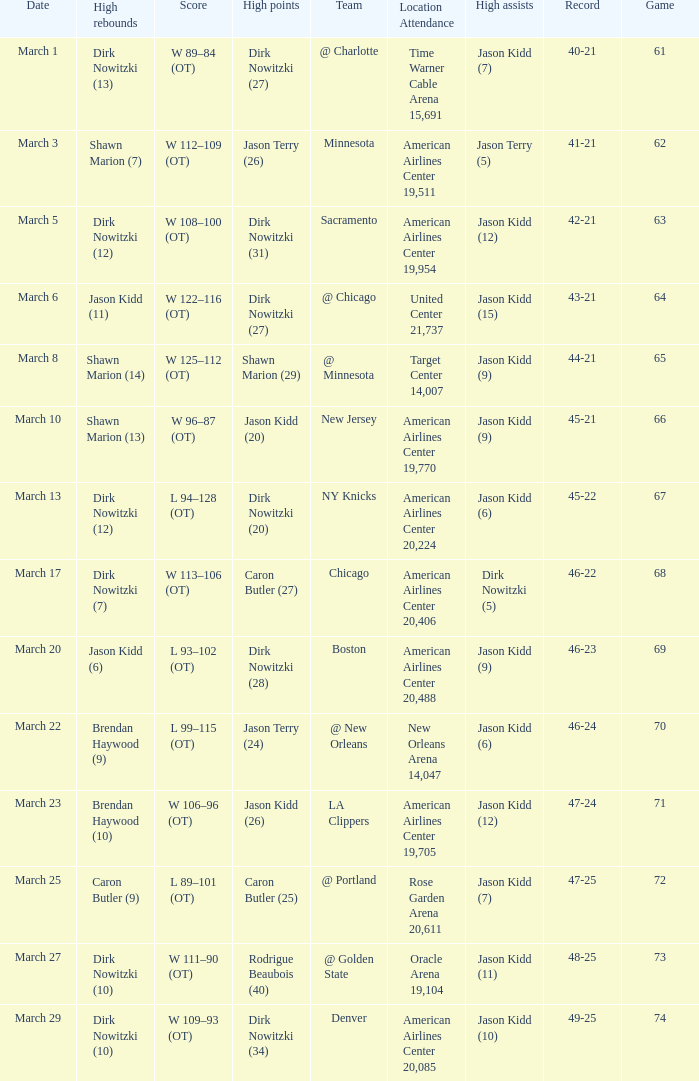How many games had been played when the Mavericks had a 46-22 record? 68.0. 